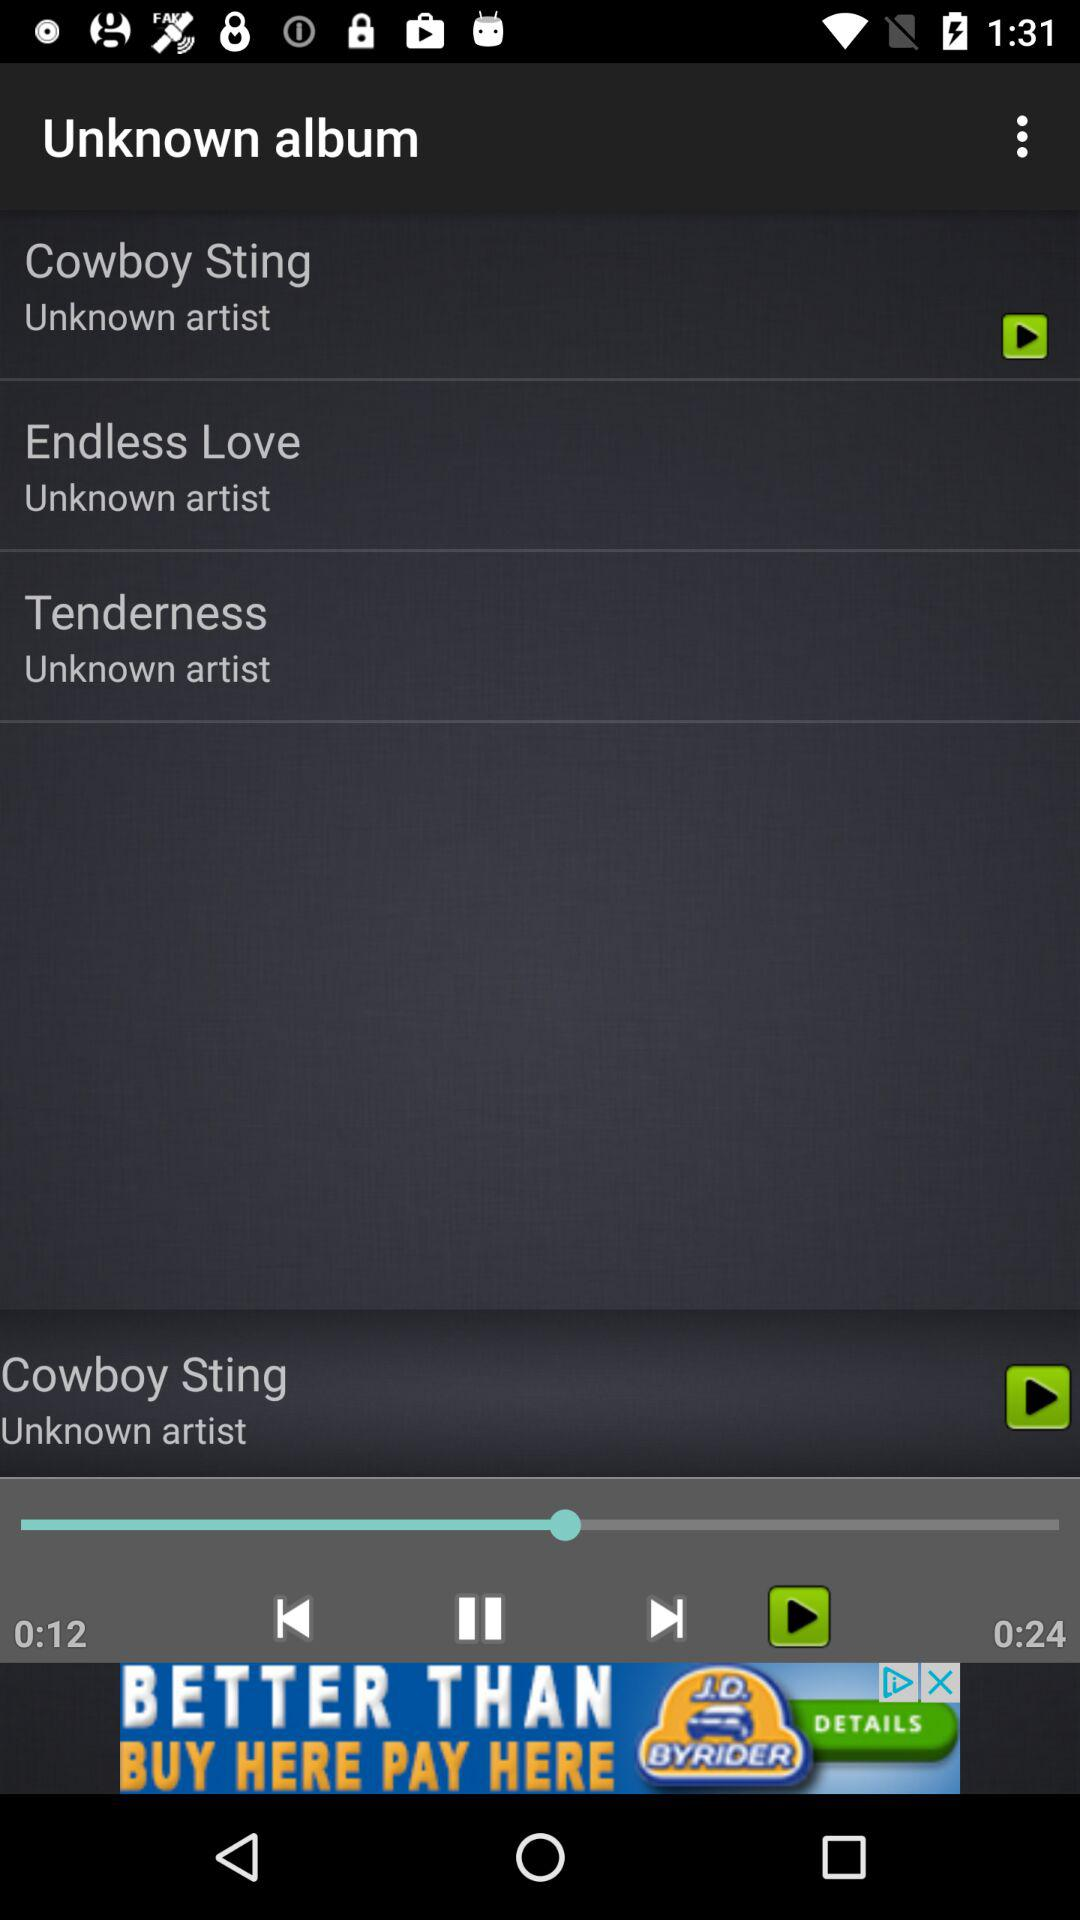Which song is playing? The song that is playing is "Cowboy Sting". 